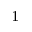Convert formula to latex. <formula><loc_0><loc_0><loc_500><loc_500>^ { 1 }</formula> 